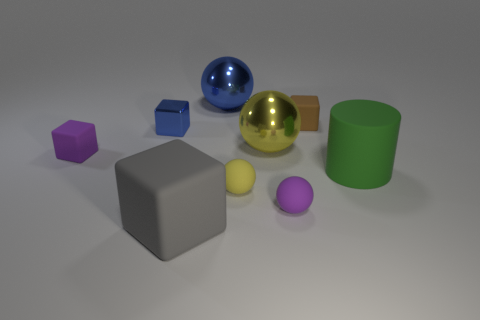What different shapes are present in the image? There are various shapes visible: two cubes, a sphere, a cylinder, and a couple of irregular polyhedra. Which item seems out of place compared to the others? All objects have a solid color and matt surface except for the metallic sphere and the metallic cube, which have reflective surfaces. These two could be considered out of place due to their unique material quality. 